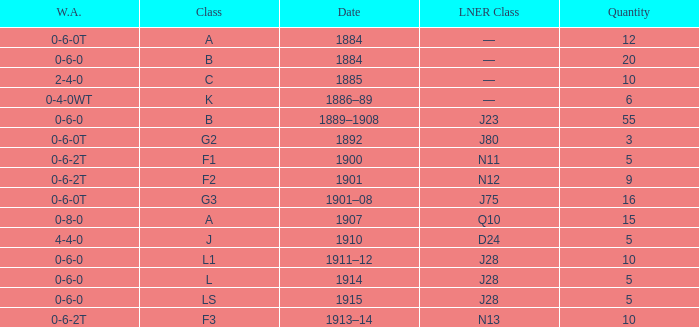What class is associated with a W.A. of 0-8-0? A. 